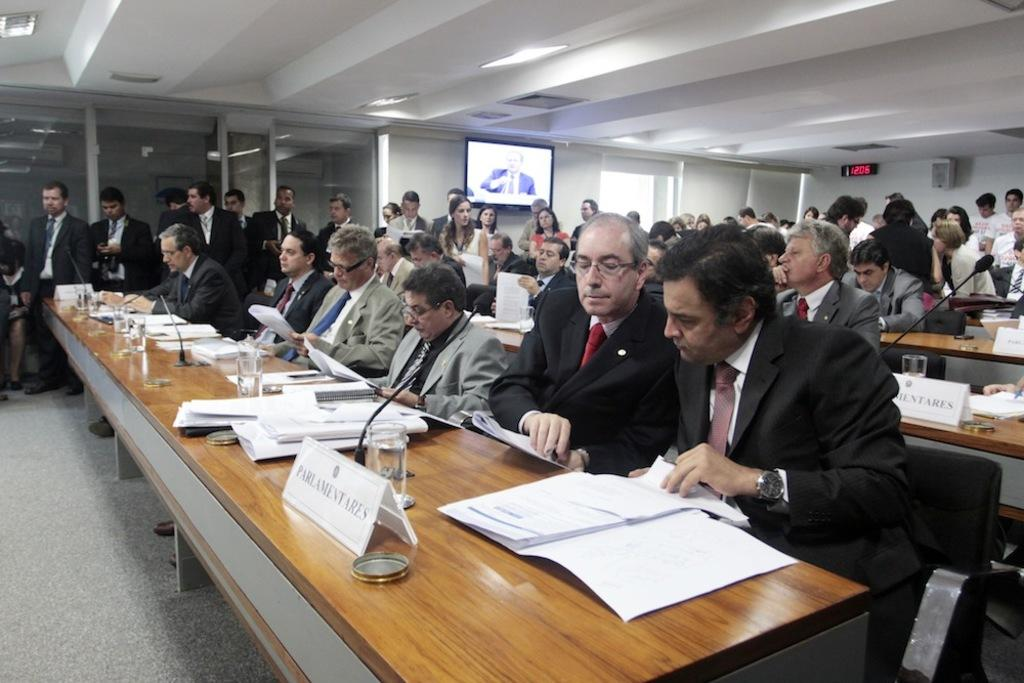How many people are in the image? There is a group of people in the image, but the exact number is not specified. Where are the people located in the image? The people are in a meeting room. What might the people be doing in the meeting room? They might be having a meeting or discussing a topic. What song is being sung by the people in the image? There is no indication in the image that the people are singing a song. 